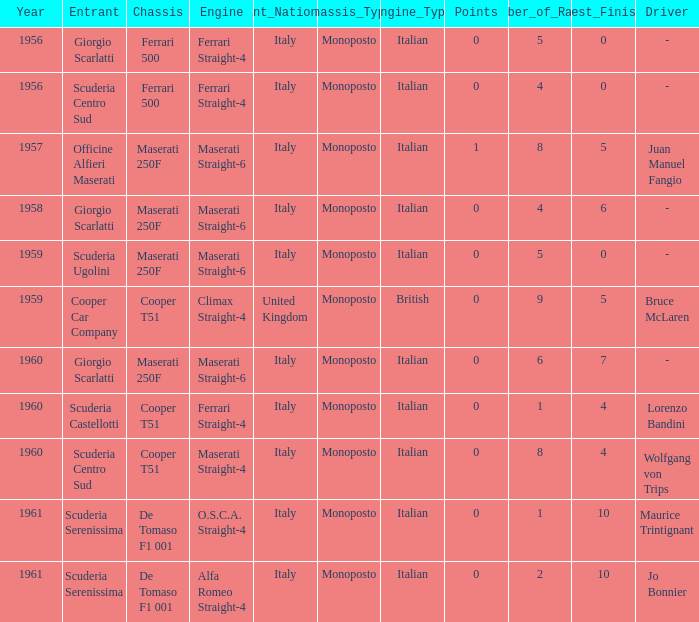How many points for the cooper car company after 1959? None. 